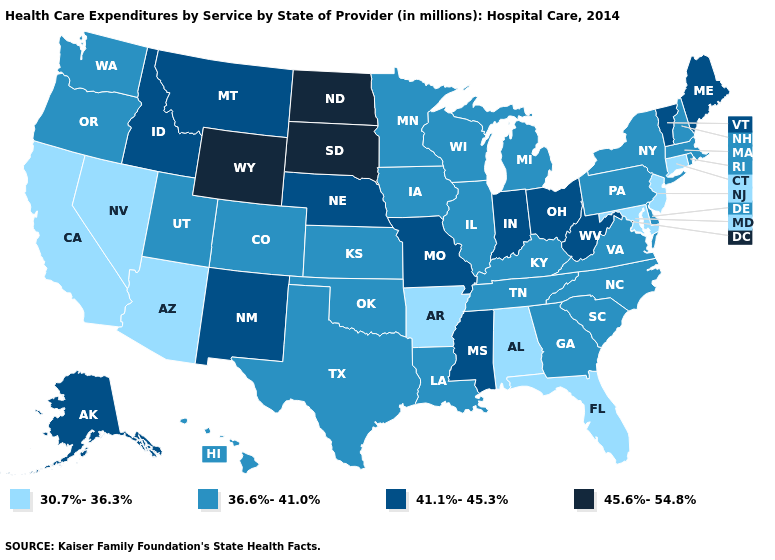Among the states that border Texas , does Arkansas have the lowest value?
Write a very short answer. Yes. What is the highest value in the USA?
Answer briefly. 45.6%-54.8%. What is the value of West Virginia?
Keep it brief. 41.1%-45.3%. What is the value of New York?
Quick response, please. 36.6%-41.0%. Name the states that have a value in the range 45.6%-54.8%?
Give a very brief answer. North Dakota, South Dakota, Wyoming. Does Washington have the lowest value in the USA?
Write a very short answer. No. Name the states that have a value in the range 41.1%-45.3%?
Write a very short answer. Alaska, Idaho, Indiana, Maine, Mississippi, Missouri, Montana, Nebraska, New Mexico, Ohio, Vermont, West Virginia. Among the states that border New Jersey , which have the highest value?
Concise answer only. Delaware, New York, Pennsylvania. Which states have the lowest value in the West?
Give a very brief answer. Arizona, California, Nevada. Name the states that have a value in the range 30.7%-36.3%?
Short answer required. Alabama, Arizona, Arkansas, California, Connecticut, Florida, Maryland, Nevada, New Jersey. What is the value of Tennessee?
Answer briefly. 36.6%-41.0%. Which states hav the highest value in the Northeast?
Answer briefly. Maine, Vermont. What is the lowest value in the USA?
Be succinct. 30.7%-36.3%. What is the value of Florida?
Concise answer only. 30.7%-36.3%. What is the value of Rhode Island?
Quick response, please. 36.6%-41.0%. 